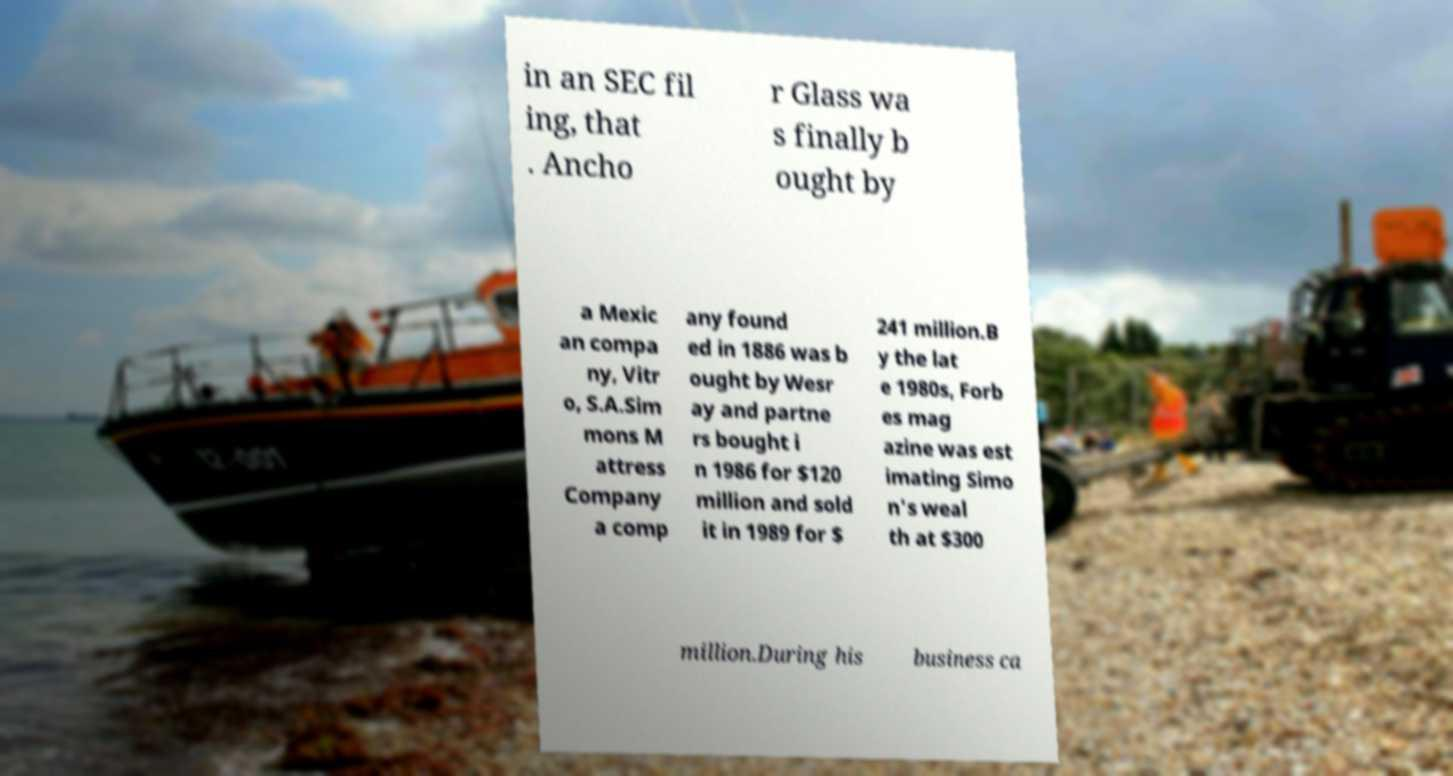I need the written content from this picture converted into text. Can you do that? in an SEC fil ing, that . Ancho r Glass wa s finally b ought by a Mexic an compa ny, Vitr o, S.A.Sim mons M attress Company a comp any found ed in 1886 was b ought by Wesr ay and partne rs bought i n 1986 for $120 million and sold it in 1989 for $ 241 million.B y the lat e 1980s, Forb es mag azine was est imating Simo n's weal th at $300 million.During his business ca 